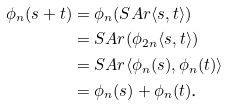Convert formula to latex. <formula><loc_0><loc_0><loc_500><loc_500>\phi _ { n } ( s + t ) & = \phi _ { n } ( S A r \langle s , t \rangle ) \\ & = S A r ( \phi _ { 2 n } \langle s , t \rangle ) \\ & = S A r \langle \phi _ { n } ( s ) , \phi _ { n } ( t ) \rangle \\ & = \phi _ { n } ( s ) + \phi _ { n } ( t ) \text  .</formula> 